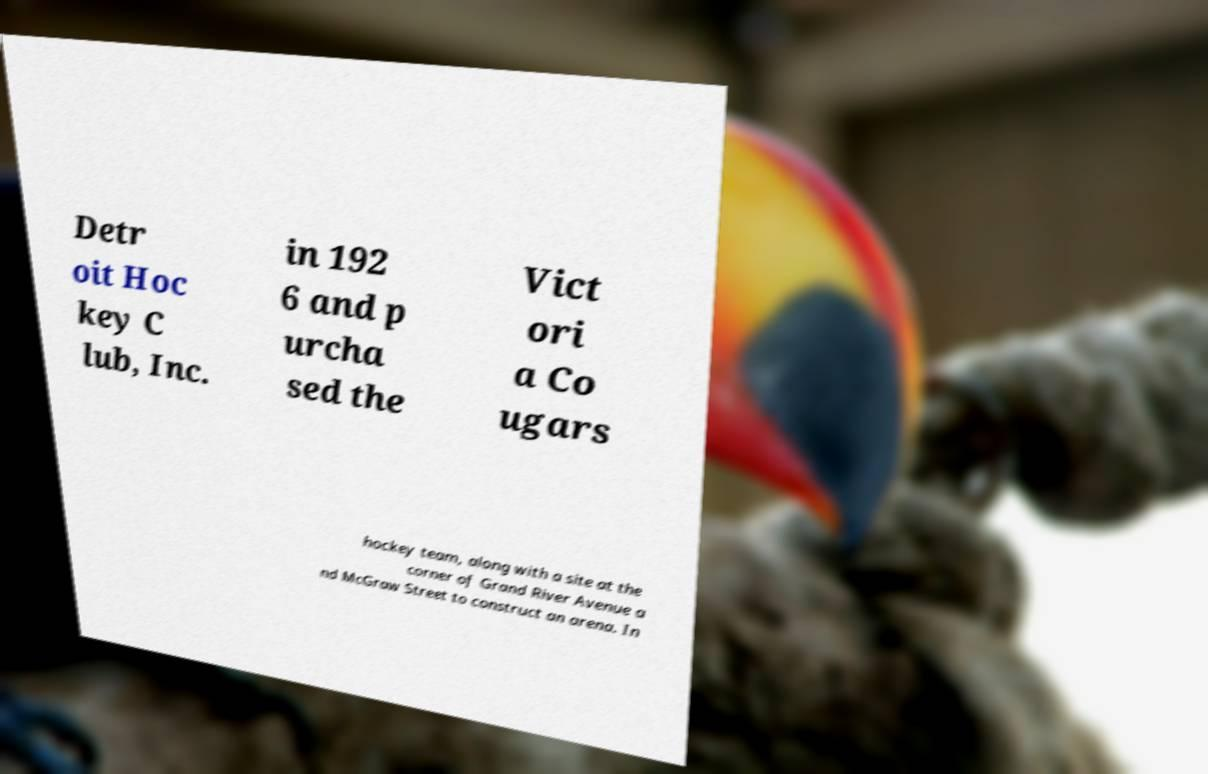Please identify and transcribe the text found in this image. Detr oit Hoc key C lub, Inc. in 192 6 and p urcha sed the Vict ori a Co ugars hockey team, along with a site at the corner of Grand River Avenue a nd McGraw Street to construct an arena. In 